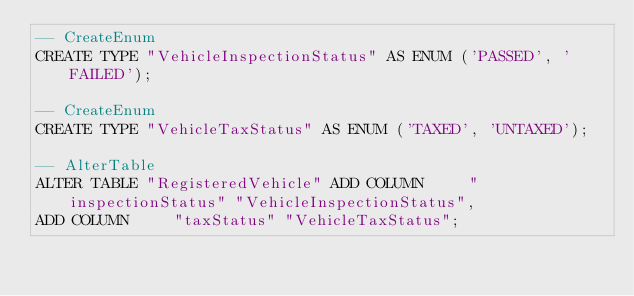<code> <loc_0><loc_0><loc_500><loc_500><_SQL_>-- CreateEnum
CREATE TYPE "VehicleInspectionStatus" AS ENUM ('PASSED', 'FAILED');

-- CreateEnum
CREATE TYPE "VehicleTaxStatus" AS ENUM ('TAXED', 'UNTAXED');

-- AlterTable
ALTER TABLE "RegisteredVehicle" ADD COLUMN     "inspectionStatus" "VehicleInspectionStatus",
ADD COLUMN     "taxStatus" "VehicleTaxStatus";
</code> 